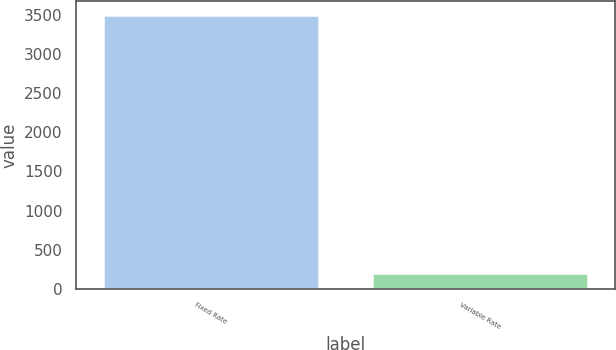Convert chart. <chart><loc_0><loc_0><loc_500><loc_500><bar_chart><fcel>Fixed Rate<fcel>Variable Rate<nl><fcel>3500<fcel>207<nl></chart> 